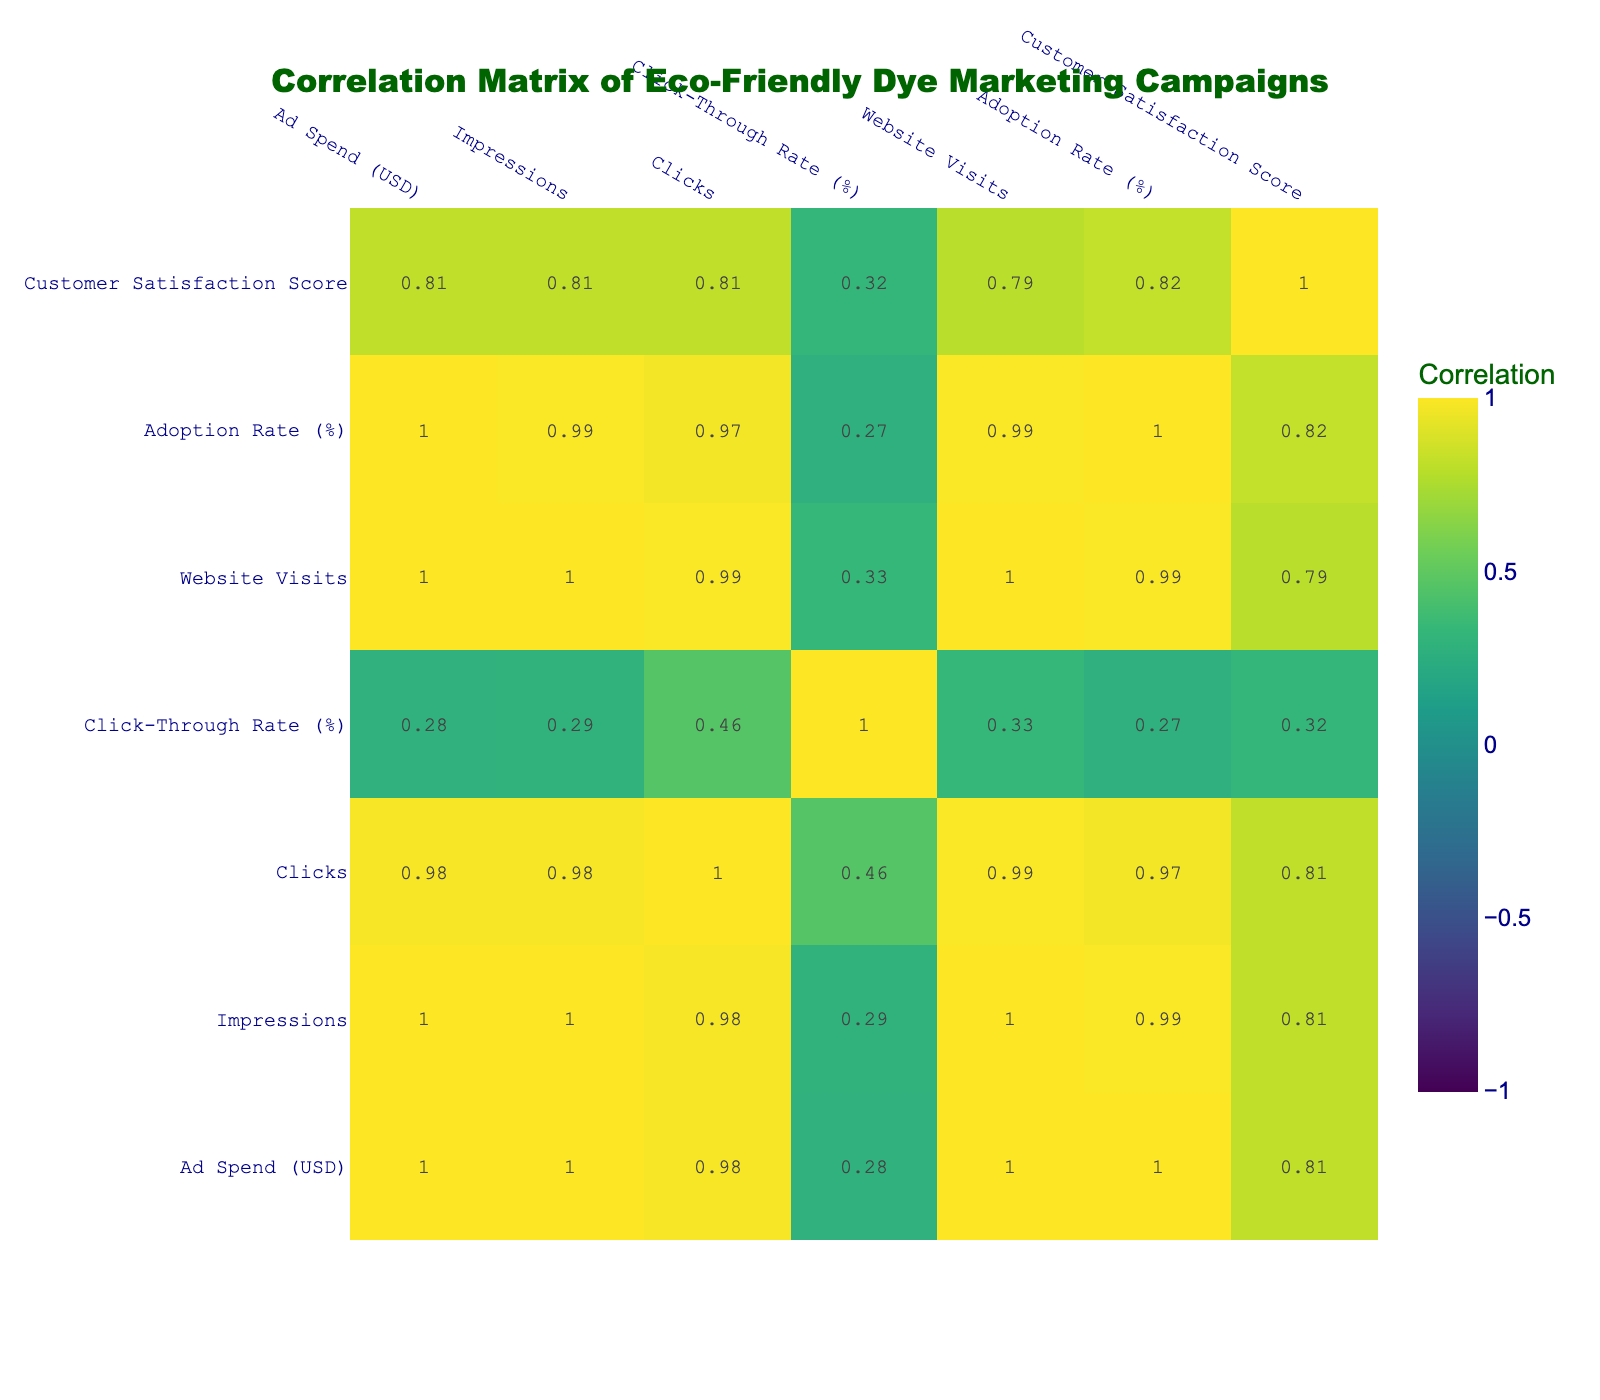What is the highest adoption rate among the campaigns? By reviewing the "Adoption Rate (%)" column, we see the highest value is 35% from the "Dye the World Green" campaign.
Answer: 35% What is the correlation between Ad Spend and Website Visits? Looking at the correlation matrix, the value corresponding to "Ad Spend" and "Website Visits" is 0.89, indicating a strong positive correlation.
Answer: 0.89 Which campaign had the lowest Customer Satisfaction Score? By examining the "Customer Satisfaction Score" column, the "Healthy Colors" campaign has the lowest score of 4.4.
Answer: 4.4 What is the average Click-Through Rate for all campaigns? The Click-Through Rates are 1.5, 1.6, 1.67, 1.45, 1.67, 1.5, and 1.61. Adding these values gives 10.2, and dividing by 7 (the number of campaigns) results in an average of approximately 1.46.
Answer: 1.46 Is there a campaign with more than 4000 Clicks that also has an Adoption Rate lower than 30%? Checking the "Clicks" and "Adoption Rate (%)" columns, the "Pure Eco Shades" campaign has 4500 Clicks and an Adoption Rate of 33%, which does not meet the condition. Therefore, the answer is no.
Answer: No What is the difference in Ad Spend between the highest and lowest campaigns? The Ad Spend for the highest campaign ("Dye the World Green") is 70000 USD, and for the lowest campaign ("Green Innovations") it is 40000 USD. The difference is 70000 - 40000 = 30000 USD.
Answer: 30000 USD How do the impressions correlate with the Customer Satisfaction Score? Evaluating the correlation matrix, the correlation between "Impressions" and "Customer Satisfaction Score" is -0.12, indicating little to no correlation between these two variables.
Answer: -0.12 Which campaign had the highest number of impressions and what was its Click-Through Rate? The "Dye the World Green" campaign had the highest number of impressions at 300000, with a Click-Through Rate of 1.67%.
Answer: 1.67% What is the average Customer Satisfaction Score for campaigns with an adoption rate above 30%? The campaigns with an adoption rate above 30% are "Sustainable Future," "Dye the World Green," and "Pure Eco Shades," with scores of 4.7, 4.9, and 4.8, respectively. Adding these gives 14.4, and dividing by 3 yields an average of 4.8.
Answer: 4.8 